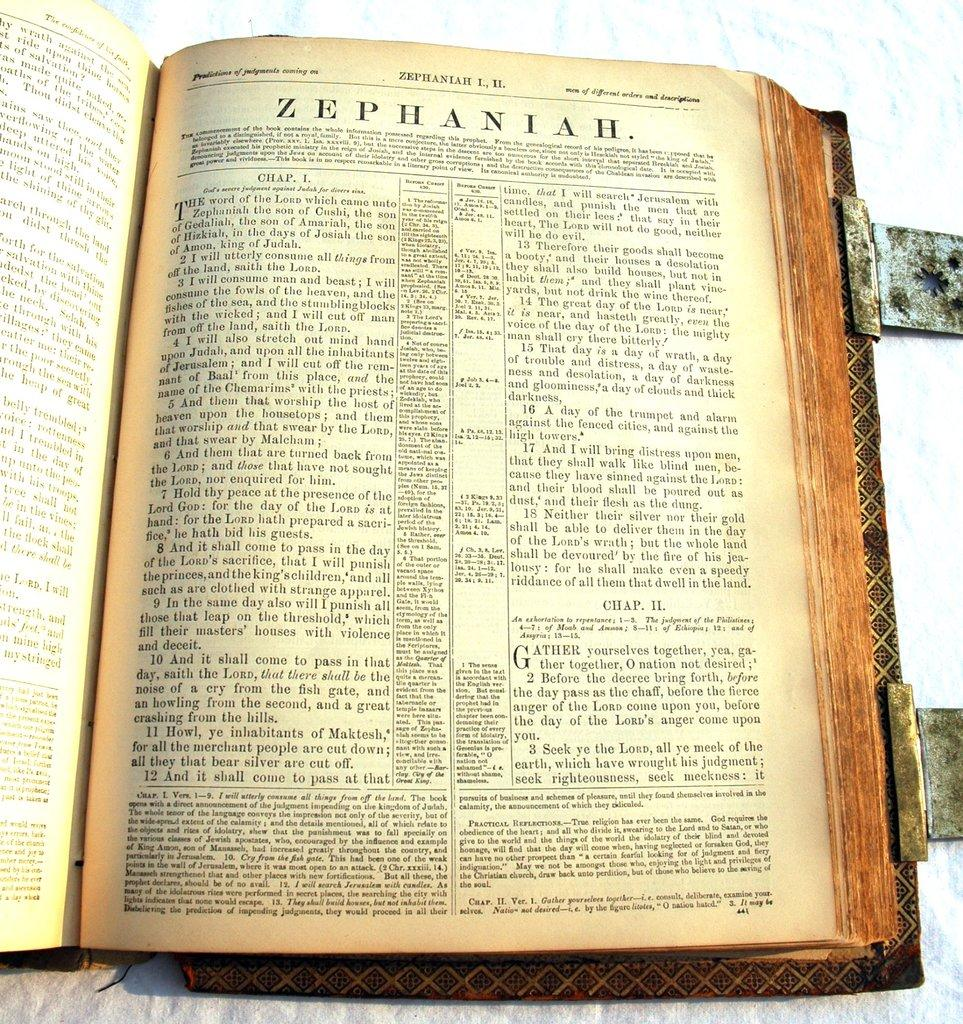Provide a one-sentence caption for the provided image. an old open book with the page open to a ZEPHANIAH wording at the top. 